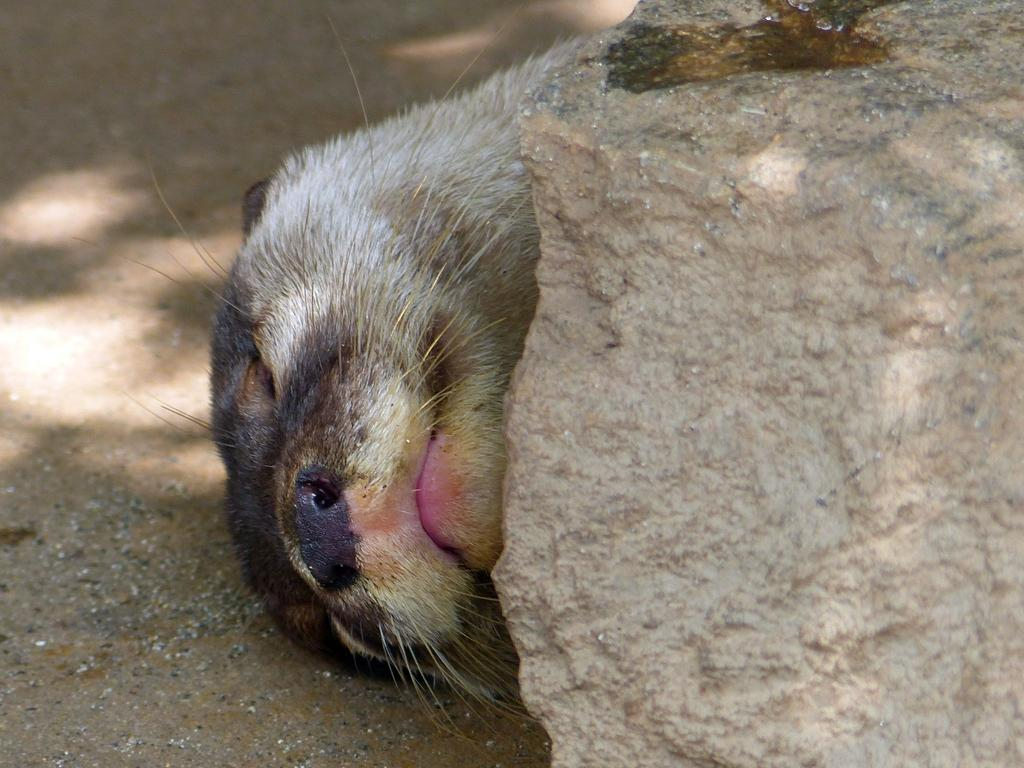What type of creature is in the image? There is an animal in the image. Where is the animal located in the image? The animal is on the ground. What other object is in the image? There is a rock in the image. How is the animal positioned in relation to the rock? The animal is beside the rock. What is the name of the animal in the image? The provided facts do not mention the name of the animal, so we cannot determine its name from the image. 